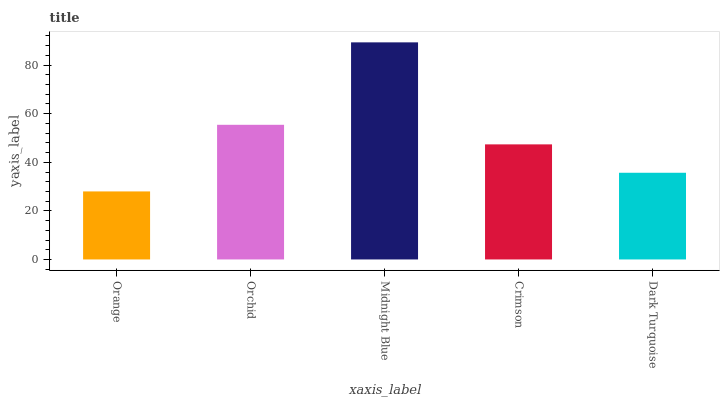Is Orange the minimum?
Answer yes or no. Yes. Is Midnight Blue the maximum?
Answer yes or no. Yes. Is Orchid the minimum?
Answer yes or no. No. Is Orchid the maximum?
Answer yes or no. No. Is Orchid greater than Orange?
Answer yes or no. Yes. Is Orange less than Orchid?
Answer yes or no. Yes. Is Orange greater than Orchid?
Answer yes or no. No. Is Orchid less than Orange?
Answer yes or no. No. Is Crimson the high median?
Answer yes or no. Yes. Is Crimson the low median?
Answer yes or no. Yes. Is Orchid the high median?
Answer yes or no. No. Is Dark Turquoise the low median?
Answer yes or no. No. 